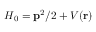Convert formula to latex. <formula><loc_0><loc_0><loc_500><loc_500>H _ { 0 } = { { p } ^ { 2 } } / { 2 } + V ( r )</formula> 